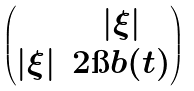Convert formula to latex. <formula><loc_0><loc_0><loc_500><loc_500>\begin{pmatrix} & | \xi | \\ | \xi | & 2 \i b ( t ) \end{pmatrix}</formula> 